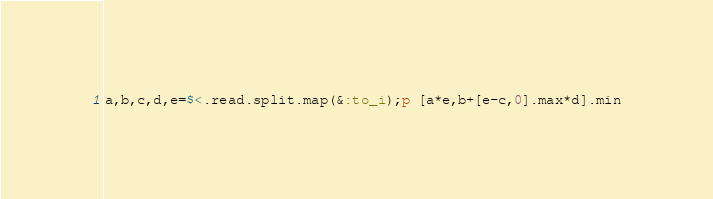Convert code to text. <code><loc_0><loc_0><loc_500><loc_500><_Ruby_>a,b,c,d,e=$<.read.split.map(&:to_i);p [a*e,b+[e-c,0].max*d].min</code> 